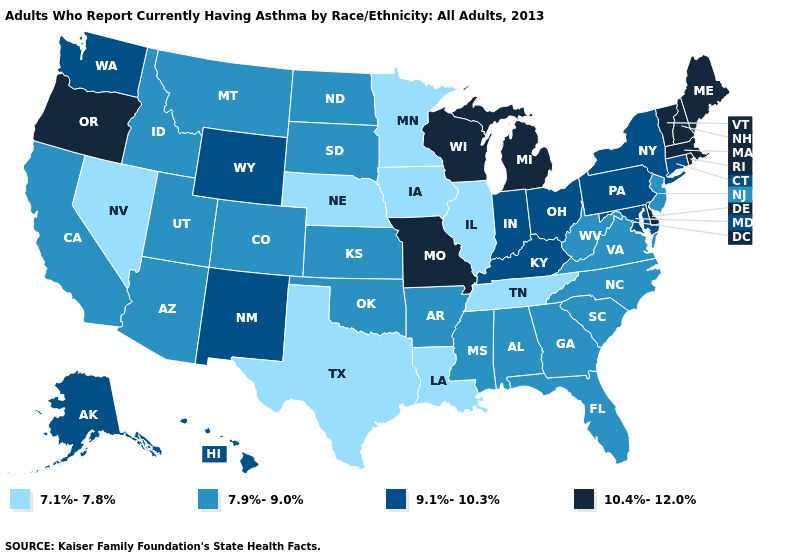Name the states that have a value in the range 9.1%-10.3%?
Give a very brief answer. Alaska, Connecticut, Hawaii, Indiana, Kentucky, Maryland, New Mexico, New York, Ohio, Pennsylvania, Washington, Wyoming. Name the states that have a value in the range 9.1%-10.3%?
Write a very short answer. Alaska, Connecticut, Hawaii, Indiana, Kentucky, Maryland, New Mexico, New York, Ohio, Pennsylvania, Washington, Wyoming. How many symbols are there in the legend?
Be succinct. 4. Among the states that border Tennessee , does Georgia have the highest value?
Be succinct. No. What is the value of Virginia?
Be succinct. 7.9%-9.0%. What is the highest value in the Northeast ?
Concise answer only. 10.4%-12.0%. What is the lowest value in states that border California?
Short answer required. 7.1%-7.8%. What is the value of Kansas?
Keep it brief. 7.9%-9.0%. What is the lowest value in the USA?
Quick response, please. 7.1%-7.8%. Name the states that have a value in the range 10.4%-12.0%?
Give a very brief answer. Delaware, Maine, Massachusetts, Michigan, Missouri, New Hampshire, Oregon, Rhode Island, Vermont, Wisconsin. What is the value of Texas?
Concise answer only. 7.1%-7.8%. Name the states that have a value in the range 10.4%-12.0%?
Keep it brief. Delaware, Maine, Massachusetts, Michigan, Missouri, New Hampshire, Oregon, Rhode Island, Vermont, Wisconsin. Does Georgia have a higher value than Nevada?
Concise answer only. Yes. What is the highest value in states that border West Virginia?
Quick response, please. 9.1%-10.3%. Name the states that have a value in the range 10.4%-12.0%?
Keep it brief. Delaware, Maine, Massachusetts, Michigan, Missouri, New Hampshire, Oregon, Rhode Island, Vermont, Wisconsin. 